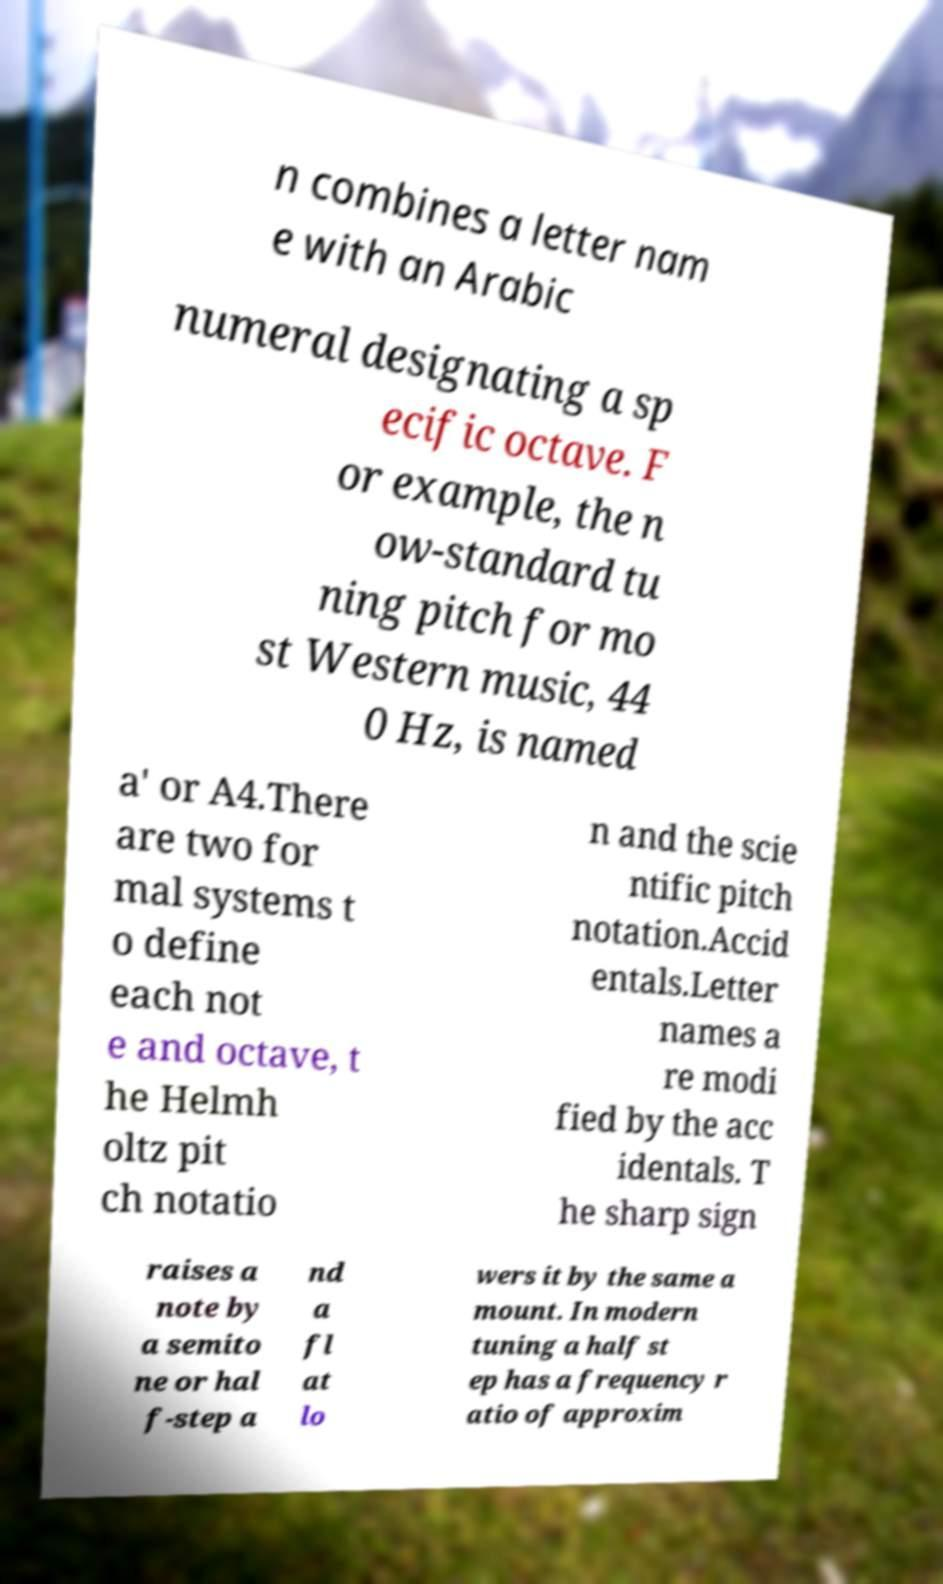What messages or text are displayed in this image? I need them in a readable, typed format. n combines a letter nam e with an Arabic numeral designating a sp ecific octave. F or example, the n ow-standard tu ning pitch for mo st Western music, 44 0 Hz, is named a′ or A4.There are two for mal systems t o define each not e and octave, t he Helmh oltz pit ch notatio n and the scie ntific pitch notation.Accid entals.Letter names a re modi fied by the acc identals. T he sharp sign raises a note by a semito ne or hal f-step a nd a fl at lo wers it by the same a mount. In modern tuning a half st ep has a frequency r atio of approxim 